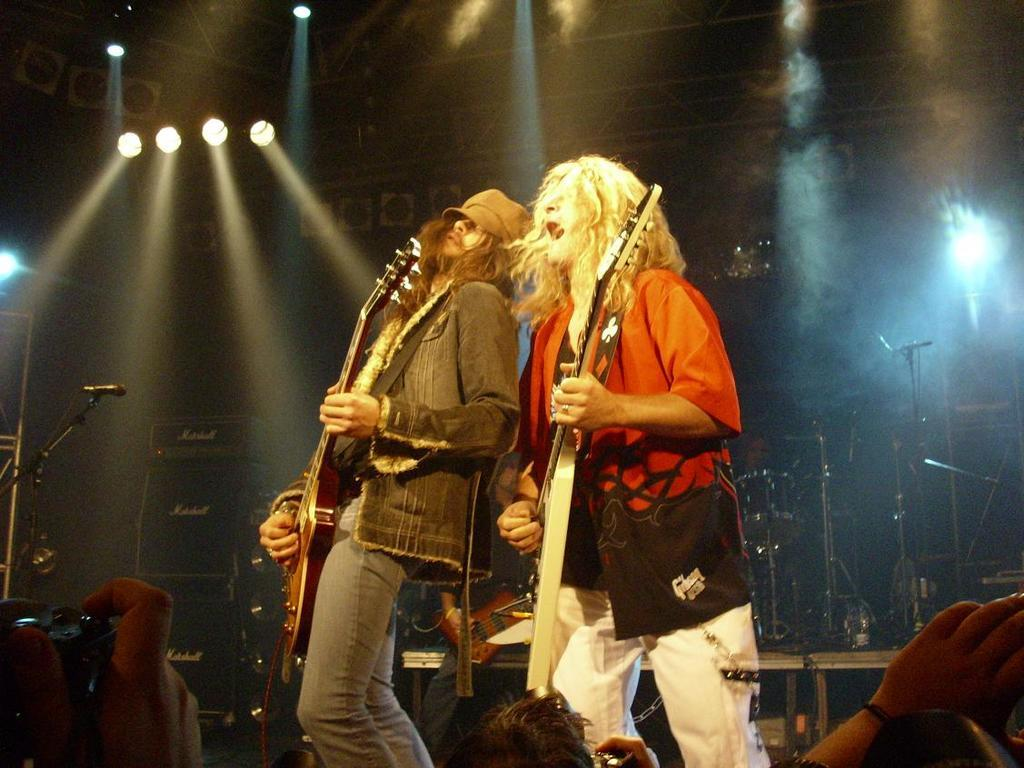What can be seen in the background of the image? In the background of the image, there are lights, drums, and microphones. What are the two persons in the image doing? The two persons are playing guitar and singing. What is the person holding in the image? The person is holding a camera. How many dimes are visible on the floor in the image? There are no dimes visible on the floor in the image. What type of help is being provided by the person holding the camera? The person holding the camera is not providing any help in the image; they are simply holding a camera. 